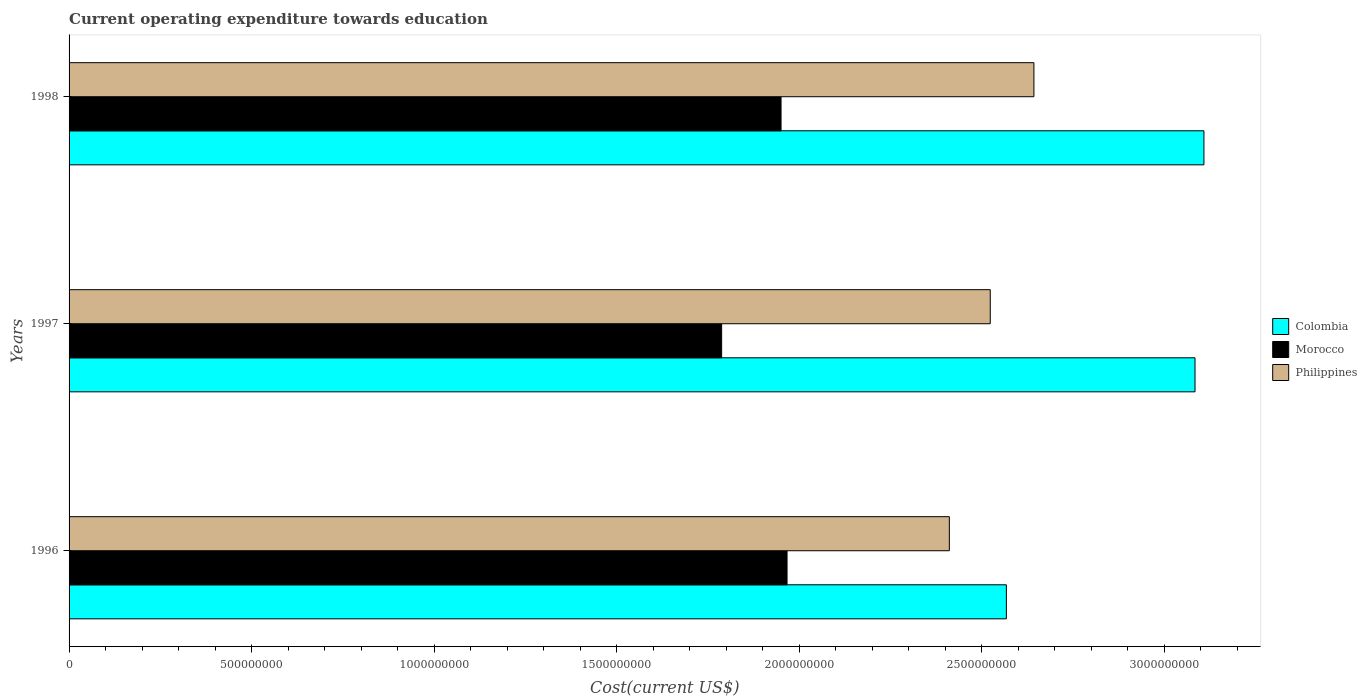How many bars are there on the 2nd tick from the top?
Make the answer very short. 3. How many bars are there on the 2nd tick from the bottom?
Offer a terse response. 3. What is the label of the 1st group of bars from the top?
Keep it short and to the point. 1998. In how many cases, is the number of bars for a given year not equal to the number of legend labels?
Offer a terse response. 0. What is the expenditure towards education in Philippines in 1998?
Keep it short and to the point. 2.64e+09. Across all years, what is the maximum expenditure towards education in Colombia?
Offer a terse response. 3.11e+09. Across all years, what is the minimum expenditure towards education in Philippines?
Give a very brief answer. 2.41e+09. In which year was the expenditure towards education in Philippines maximum?
Make the answer very short. 1998. What is the total expenditure towards education in Morocco in the graph?
Provide a succinct answer. 5.71e+09. What is the difference between the expenditure towards education in Colombia in 1997 and that in 1998?
Provide a short and direct response. -2.44e+07. What is the difference between the expenditure towards education in Colombia in 1996 and the expenditure towards education in Philippines in 1997?
Keep it short and to the point. 4.41e+07. What is the average expenditure towards education in Colombia per year?
Keep it short and to the point. 2.92e+09. In the year 1996, what is the difference between the expenditure towards education in Colombia and expenditure towards education in Philippines?
Provide a short and direct response. 1.56e+08. What is the ratio of the expenditure towards education in Philippines in 1997 to that in 1998?
Offer a very short reply. 0.95. What is the difference between the highest and the second highest expenditure towards education in Philippines?
Provide a succinct answer. 1.20e+08. What is the difference between the highest and the lowest expenditure towards education in Philippines?
Your answer should be very brief. 2.32e+08. In how many years, is the expenditure towards education in Colombia greater than the average expenditure towards education in Colombia taken over all years?
Your answer should be compact. 2. Is the sum of the expenditure towards education in Morocco in 1996 and 1997 greater than the maximum expenditure towards education in Philippines across all years?
Make the answer very short. Yes. How many years are there in the graph?
Give a very brief answer. 3. What is the difference between two consecutive major ticks on the X-axis?
Offer a terse response. 5.00e+08. Are the values on the major ticks of X-axis written in scientific E-notation?
Give a very brief answer. No. Where does the legend appear in the graph?
Make the answer very short. Center right. How many legend labels are there?
Provide a short and direct response. 3. What is the title of the graph?
Give a very brief answer. Current operating expenditure towards education. Does "Belgium" appear as one of the legend labels in the graph?
Your answer should be compact. No. What is the label or title of the X-axis?
Your response must be concise. Cost(current US$). What is the label or title of the Y-axis?
Your answer should be very brief. Years. What is the Cost(current US$) in Colombia in 1996?
Keep it short and to the point. 2.57e+09. What is the Cost(current US$) of Morocco in 1996?
Your answer should be very brief. 1.97e+09. What is the Cost(current US$) of Philippines in 1996?
Provide a succinct answer. 2.41e+09. What is the Cost(current US$) of Colombia in 1997?
Your answer should be compact. 3.08e+09. What is the Cost(current US$) of Morocco in 1997?
Offer a very short reply. 1.79e+09. What is the Cost(current US$) of Philippines in 1997?
Ensure brevity in your answer.  2.52e+09. What is the Cost(current US$) in Colombia in 1998?
Keep it short and to the point. 3.11e+09. What is the Cost(current US$) in Morocco in 1998?
Offer a terse response. 1.95e+09. What is the Cost(current US$) in Philippines in 1998?
Provide a short and direct response. 2.64e+09. Across all years, what is the maximum Cost(current US$) of Colombia?
Keep it short and to the point. 3.11e+09. Across all years, what is the maximum Cost(current US$) in Morocco?
Ensure brevity in your answer.  1.97e+09. Across all years, what is the maximum Cost(current US$) of Philippines?
Ensure brevity in your answer.  2.64e+09. Across all years, what is the minimum Cost(current US$) of Colombia?
Give a very brief answer. 2.57e+09. Across all years, what is the minimum Cost(current US$) in Morocco?
Your response must be concise. 1.79e+09. Across all years, what is the minimum Cost(current US$) of Philippines?
Your answer should be very brief. 2.41e+09. What is the total Cost(current US$) of Colombia in the graph?
Ensure brevity in your answer.  8.76e+09. What is the total Cost(current US$) of Morocco in the graph?
Your answer should be compact. 5.71e+09. What is the total Cost(current US$) in Philippines in the graph?
Ensure brevity in your answer.  7.58e+09. What is the difference between the Cost(current US$) of Colombia in 1996 and that in 1997?
Ensure brevity in your answer.  -5.17e+08. What is the difference between the Cost(current US$) in Morocco in 1996 and that in 1997?
Make the answer very short. 1.79e+08. What is the difference between the Cost(current US$) in Philippines in 1996 and that in 1997?
Your answer should be compact. -1.12e+08. What is the difference between the Cost(current US$) in Colombia in 1996 and that in 1998?
Your answer should be compact. -5.41e+08. What is the difference between the Cost(current US$) of Morocco in 1996 and that in 1998?
Offer a terse response. 1.64e+07. What is the difference between the Cost(current US$) in Philippines in 1996 and that in 1998?
Ensure brevity in your answer.  -2.32e+08. What is the difference between the Cost(current US$) in Colombia in 1997 and that in 1998?
Provide a succinct answer. -2.44e+07. What is the difference between the Cost(current US$) in Morocco in 1997 and that in 1998?
Provide a short and direct response. -1.63e+08. What is the difference between the Cost(current US$) in Philippines in 1997 and that in 1998?
Ensure brevity in your answer.  -1.20e+08. What is the difference between the Cost(current US$) of Colombia in 1996 and the Cost(current US$) of Morocco in 1997?
Provide a succinct answer. 7.80e+08. What is the difference between the Cost(current US$) of Colombia in 1996 and the Cost(current US$) of Philippines in 1997?
Your answer should be compact. 4.41e+07. What is the difference between the Cost(current US$) of Morocco in 1996 and the Cost(current US$) of Philippines in 1997?
Provide a succinct answer. -5.57e+08. What is the difference between the Cost(current US$) of Colombia in 1996 and the Cost(current US$) of Morocco in 1998?
Your answer should be compact. 6.17e+08. What is the difference between the Cost(current US$) in Colombia in 1996 and the Cost(current US$) in Philippines in 1998?
Provide a short and direct response. -7.55e+07. What is the difference between the Cost(current US$) of Morocco in 1996 and the Cost(current US$) of Philippines in 1998?
Offer a terse response. -6.76e+08. What is the difference between the Cost(current US$) of Colombia in 1997 and the Cost(current US$) of Morocco in 1998?
Keep it short and to the point. 1.13e+09. What is the difference between the Cost(current US$) in Colombia in 1997 and the Cost(current US$) in Philippines in 1998?
Your answer should be very brief. 4.41e+08. What is the difference between the Cost(current US$) of Morocco in 1997 and the Cost(current US$) of Philippines in 1998?
Your answer should be compact. -8.56e+08. What is the average Cost(current US$) in Colombia per year?
Your answer should be very brief. 2.92e+09. What is the average Cost(current US$) in Morocco per year?
Provide a succinct answer. 1.90e+09. What is the average Cost(current US$) of Philippines per year?
Your answer should be very brief. 2.53e+09. In the year 1996, what is the difference between the Cost(current US$) of Colombia and Cost(current US$) of Morocco?
Offer a terse response. 6.01e+08. In the year 1996, what is the difference between the Cost(current US$) in Colombia and Cost(current US$) in Philippines?
Offer a very short reply. 1.56e+08. In the year 1996, what is the difference between the Cost(current US$) in Morocco and Cost(current US$) in Philippines?
Offer a very short reply. -4.45e+08. In the year 1997, what is the difference between the Cost(current US$) in Colombia and Cost(current US$) in Morocco?
Your answer should be compact. 1.30e+09. In the year 1997, what is the difference between the Cost(current US$) of Colombia and Cost(current US$) of Philippines?
Your answer should be compact. 5.61e+08. In the year 1997, what is the difference between the Cost(current US$) of Morocco and Cost(current US$) of Philippines?
Ensure brevity in your answer.  -7.36e+08. In the year 1998, what is the difference between the Cost(current US$) in Colombia and Cost(current US$) in Morocco?
Provide a short and direct response. 1.16e+09. In the year 1998, what is the difference between the Cost(current US$) of Colombia and Cost(current US$) of Philippines?
Offer a very short reply. 4.66e+08. In the year 1998, what is the difference between the Cost(current US$) in Morocco and Cost(current US$) in Philippines?
Give a very brief answer. -6.93e+08. What is the ratio of the Cost(current US$) of Colombia in 1996 to that in 1997?
Your response must be concise. 0.83. What is the ratio of the Cost(current US$) of Morocco in 1996 to that in 1997?
Your answer should be compact. 1.1. What is the ratio of the Cost(current US$) in Philippines in 1996 to that in 1997?
Offer a very short reply. 0.96. What is the ratio of the Cost(current US$) in Colombia in 1996 to that in 1998?
Your response must be concise. 0.83. What is the ratio of the Cost(current US$) in Morocco in 1996 to that in 1998?
Provide a short and direct response. 1.01. What is the ratio of the Cost(current US$) of Philippines in 1996 to that in 1998?
Make the answer very short. 0.91. What is the ratio of the Cost(current US$) of Morocco in 1997 to that in 1998?
Your answer should be compact. 0.92. What is the ratio of the Cost(current US$) of Philippines in 1997 to that in 1998?
Offer a very short reply. 0.95. What is the difference between the highest and the second highest Cost(current US$) of Colombia?
Give a very brief answer. 2.44e+07. What is the difference between the highest and the second highest Cost(current US$) in Morocco?
Your answer should be very brief. 1.64e+07. What is the difference between the highest and the second highest Cost(current US$) of Philippines?
Your answer should be compact. 1.20e+08. What is the difference between the highest and the lowest Cost(current US$) in Colombia?
Keep it short and to the point. 5.41e+08. What is the difference between the highest and the lowest Cost(current US$) of Morocco?
Your answer should be compact. 1.79e+08. What is the difference between the highest and the lowest Cost(current US$) in Philippines?
Offer a very short reply. 2.32e+08. 